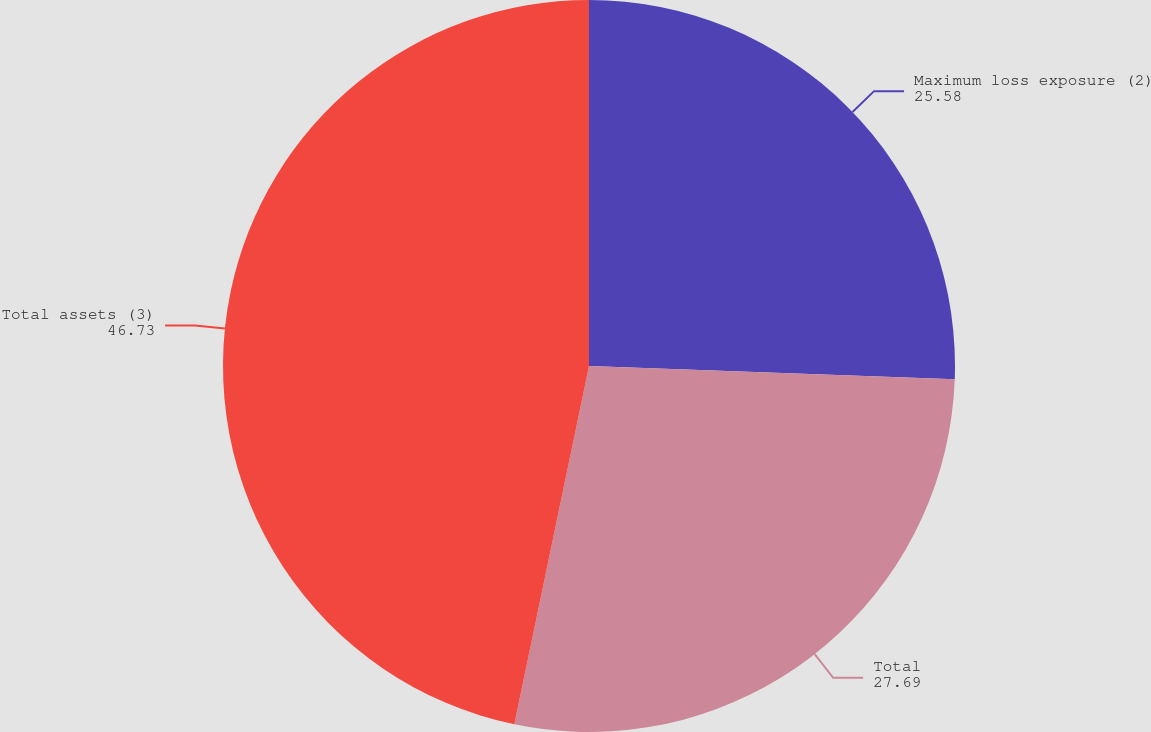<chart> <loc_0><loc_0><loc_500><loc_500><pie_chart><fcel>Maximum loss exposure (2)<fcel>Total<fcel>Total assets (3)<nl><fcel>25.58%<fcel>27.69%<fcel>46.73%<nl></chart> 